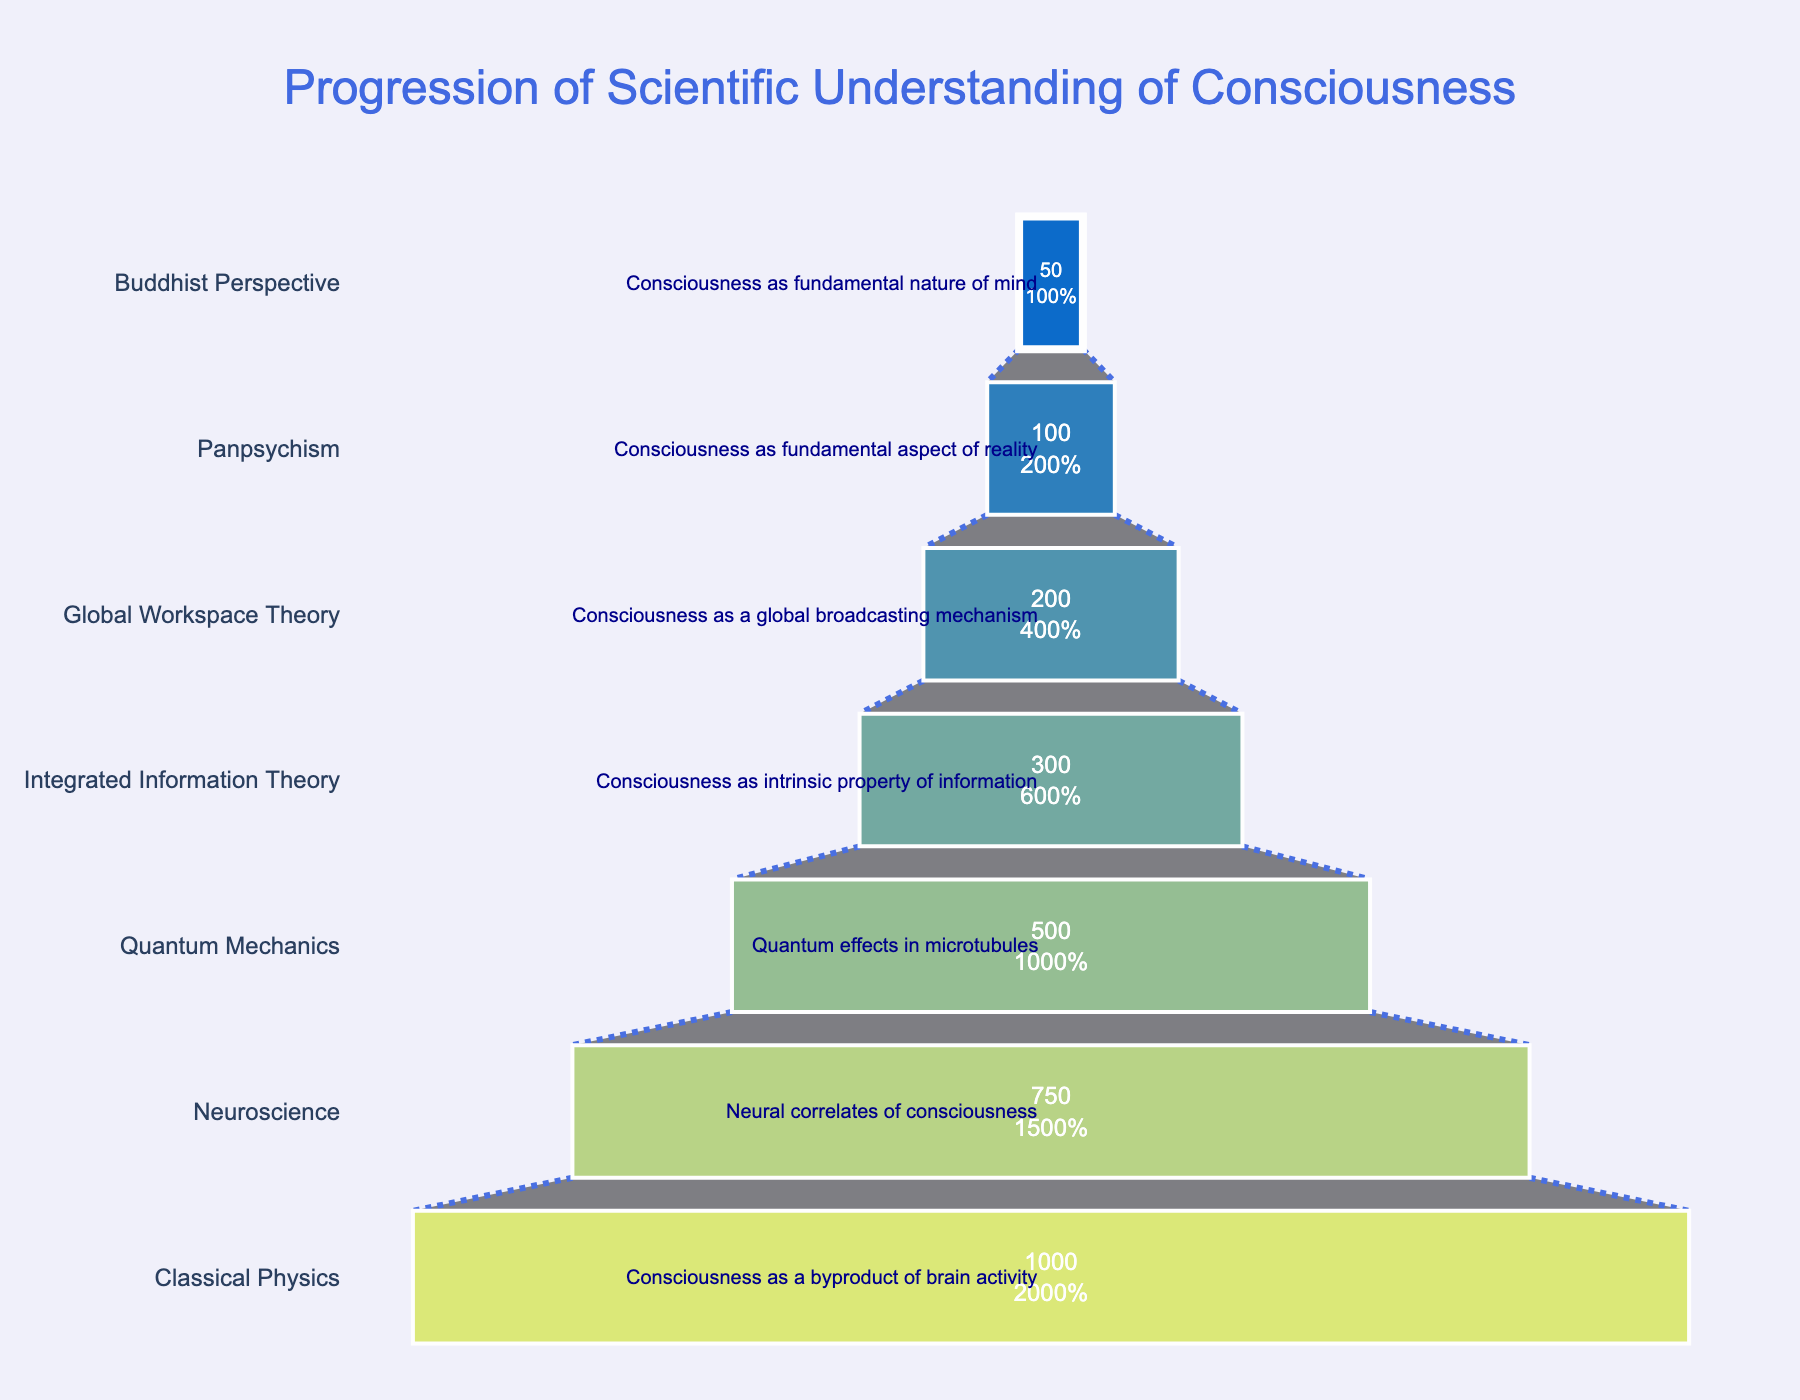what is the title of the funnel chart? The title of the funnel chart is written at the top of the figure. It reads "Progression of Scientific Understanding of Consciousness."
Answer: Progression of Scientific Understanding of Consciousness which stage has the most researchers? The stage with the most number of researchers is indicated by the widest section of the funnel chart. That stage is "Classical Physics" with 1000 researchers.
Answer: Classical Physics how many stages are displayed in the funnel chart? Each stage is represented by a section of the funnel chart. Counting these sections, there are 7 stages displayed in the chart.
Answer: 7 compare the number of researchers in neuroscience to integrated information theory. which has more? The chart shows that Neuroscience has 750 researchers, and Integrated Information Theory has 300 researchers. Neuroscience has more researchers.
Answer: Neuroscience what is the overall trend shown by the number of researchers across different stages? Observing the funnel chart, the number of researchers consistently decreases from the "Classical Physics" stage to the "Buddhist Perspective" stage. This shows a downward trend in the number of researchers as we move through the stages.
Answer: Decreasing what percentage do researchers in global workspace theory form of the initial group in classical physics? First, find the number of researchers in Classical Physics (1000) and Global Workspace Theory (200). The percentage is calculated as (200/1000) * 100.
Answer: 20% what are the scientific understandings at the two stages with the least researchers? The two stages with the least researchers are "Panpsychism" and "Buddhist Perspective." The scientific understandings at these stages are "Consciousness as fundamental aspect of reality" and "Consciousness as fundamental nature of mind," respectively.
Answer: Consciousness as fundamental aspect of reality; Consciousness as fundamental nature of mind between which consecutive stages is the largest drop in the number of researchers observed? To determine the largest drop, we need to look at the differences between consecutive stages: 
Classical Physics (1000) to Neuroscience (750): drop of 250, 
Neuroscience (750) to Quantum Mechanics (500): drop of 250,
Quantum Mechanics (500) to Integrated Information Theory (300): drop of 200,
Integrated Information Theory (300) to Global Workspace Theory (200): drop of 100,
Global Workspace Theory (200) to Panpsychism (100): drop of 100,
Panpsychism (100) to Buddhist Perspective (50): drop of 50.
The largest drop in the number of researchers is seen between Classical Physics to Neuroscience and Neuroscience to Quantum Mechanics, both being 250.
Answer: Classical Physics to Neuroscience and Neuroscience to Quantum Mechanics what does the color gradient in the funnel chart represent? The color gradient used in the funnel chart ranges from light to dark, representing the progression through the stages from the top (Classical Physics) to the bottom (Buddhist Perspective). This visually differentiates each stage and provides a sense of progression.
Answer: Progression through stages and differentiation 